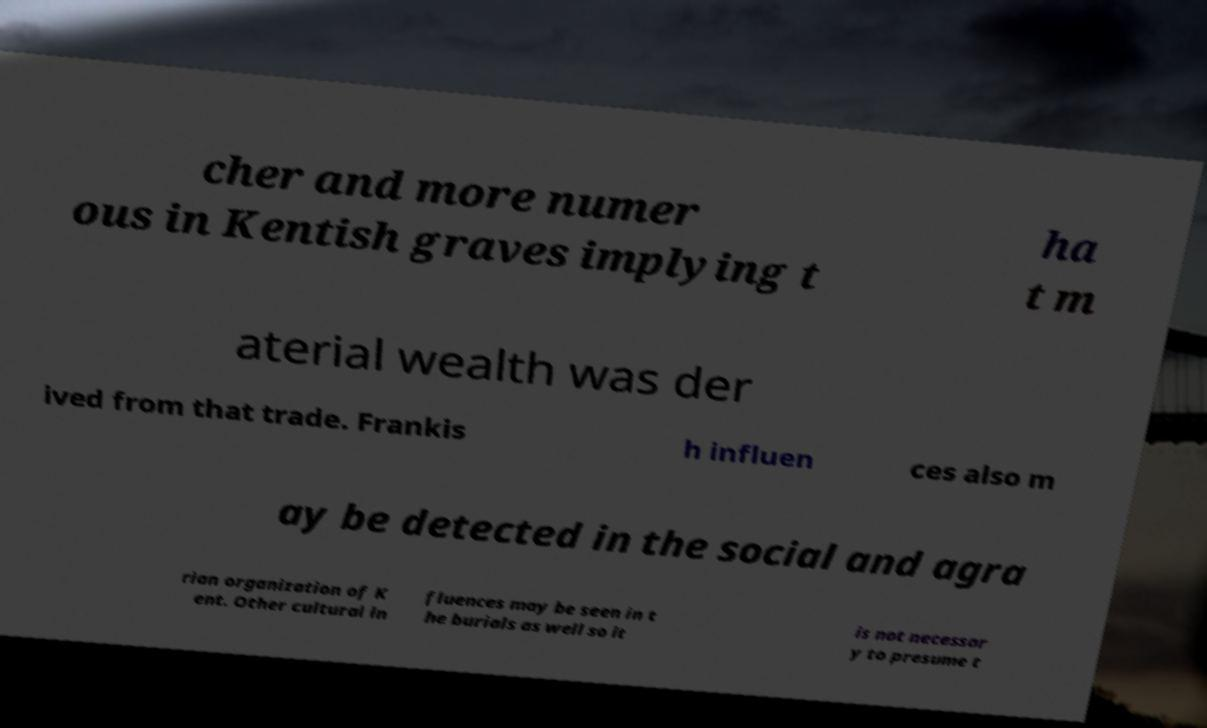What messages or text are displayed in this image? I need them in a readable, typed format. cher and more numer ous in Kentish graves implying t ha t m aterial wealth was der ived from that trade. Frankis h influen ces also m ay be detected in the social and agra rian organization of K ent. Other cultural in fluences may be seen in t he burials as well so it is not necessar y to presume t 